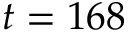Convert formula to latex. <formula><loc_0><loc_0><loc_500><loc_500>t = 1 6 8</formula> 